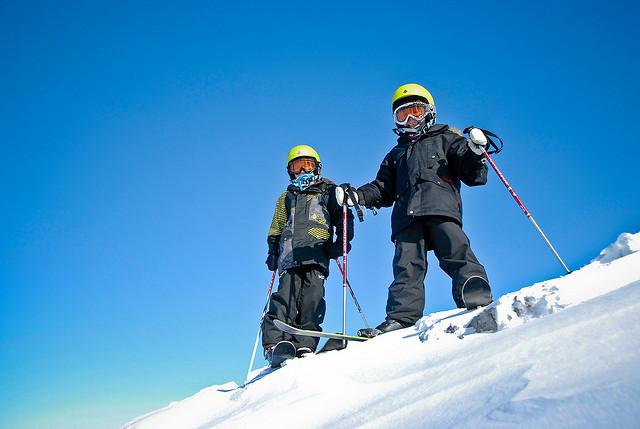Who are the top of the hill?
Concise answer only. Skiers. What are the people holding?
Be succinct. Ski poles. What are they on?
Answer briefly. Snow. 